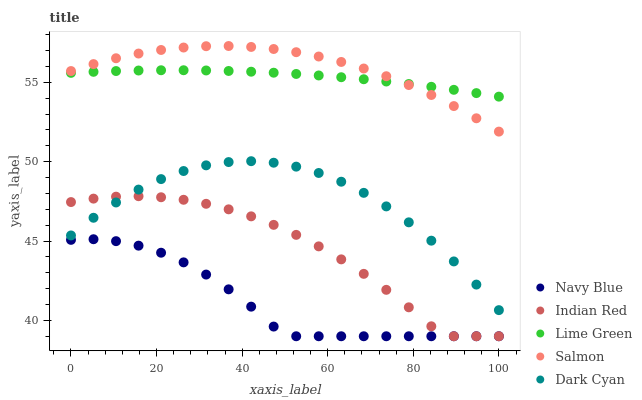Does Navy Blue have the minimum area under the curve?
Answer yes or no. Yes. Does Salmon have the maximum area under the curve?
Answer yes or no. Yes. Does Lime Green have the minimum area under the curve?
Answer yes or no. No. Does Lime Green have the maximum area under the curve?
Answer yes or no. No. Is Lime Green the smoothest?
Answer yes or no. Yes. Is Dark Cyan the roughest?
Answer yes or no. Yes. Is Navy Blue the smoothest?
Answer yes or no. No. Is Navy Blue the roughest?
Answer yes or no. No. Does Navy Blue have the lowest value?
Answer yes or no. Yes. Does Lime Green have the lowest value?
Answer yes or no. No. Does Salmon have the highest value?
Answer yes or no. Yes. Does Lime Green have the highest value?
Answer yes or no. No. Is Navy Blue less than Dark Cyan?
Answer yes or no. Yes. Is Lime Green greater than Dark Cyan?
Answer yes or no. Yes. Does Salmon intersect Lime Green?
Answer yes or no. Yes. Is Salmon less than Lime Green?
Answer yes or no. No. Is Salmon greater than Lime Green?
Answer yes or no. No. Does Navy Blue intersect Dark Cyan?
Answer yes or no. No. 